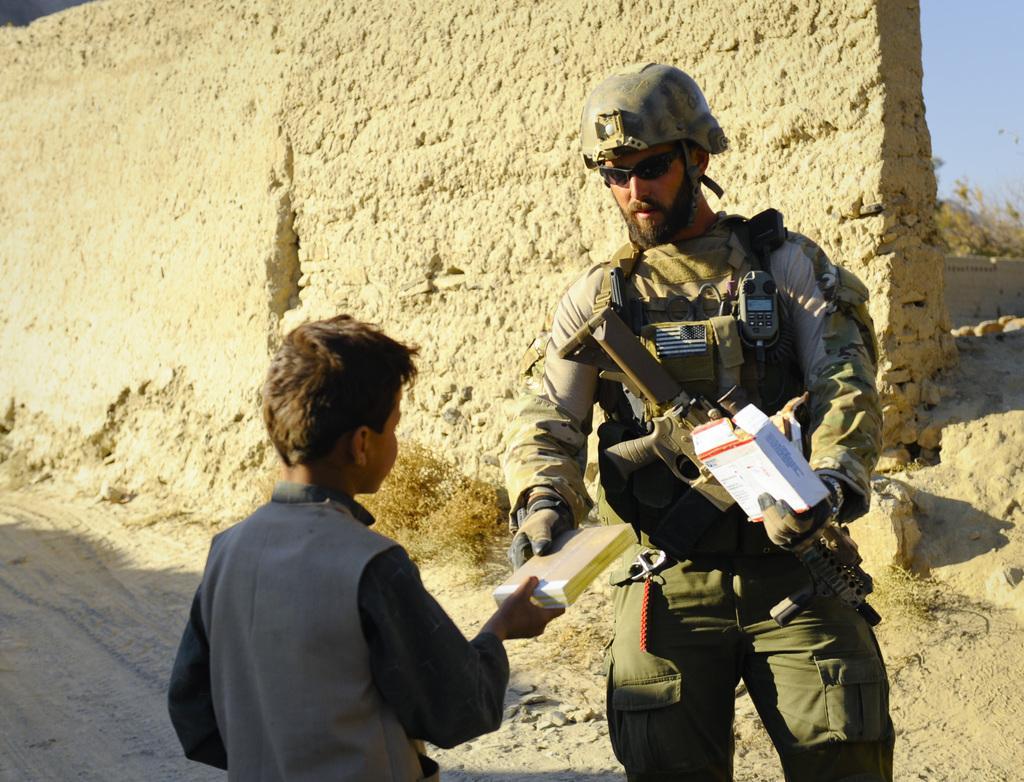How would you summarize this image in a sentence or two? In this picture we can observe a boy and a man, wearing spectacles and helmets. We can observe some dried plants. Behind him there is a wall which is in cream color. In the background there is a sky. 